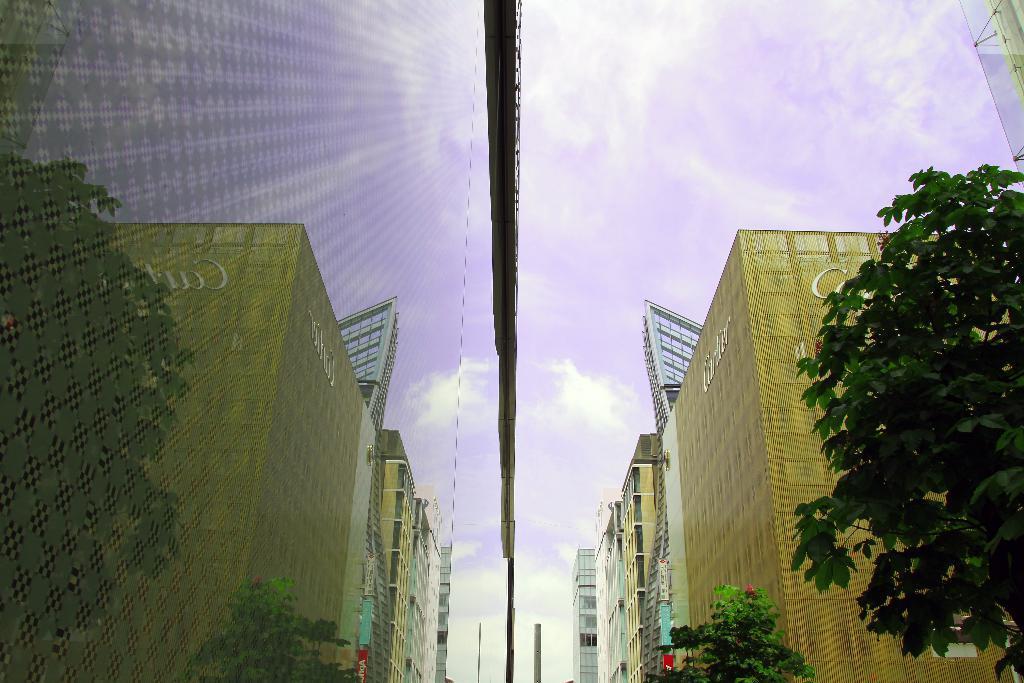Please provide a concise description of this image. In this image I can see few trees to which I can see few flowers which are red in color and I can see few buildings on both sides of the trees. I can see the glass wall of the building on which I can see the reflections of buildings and trees. In the background I can see the sky. 